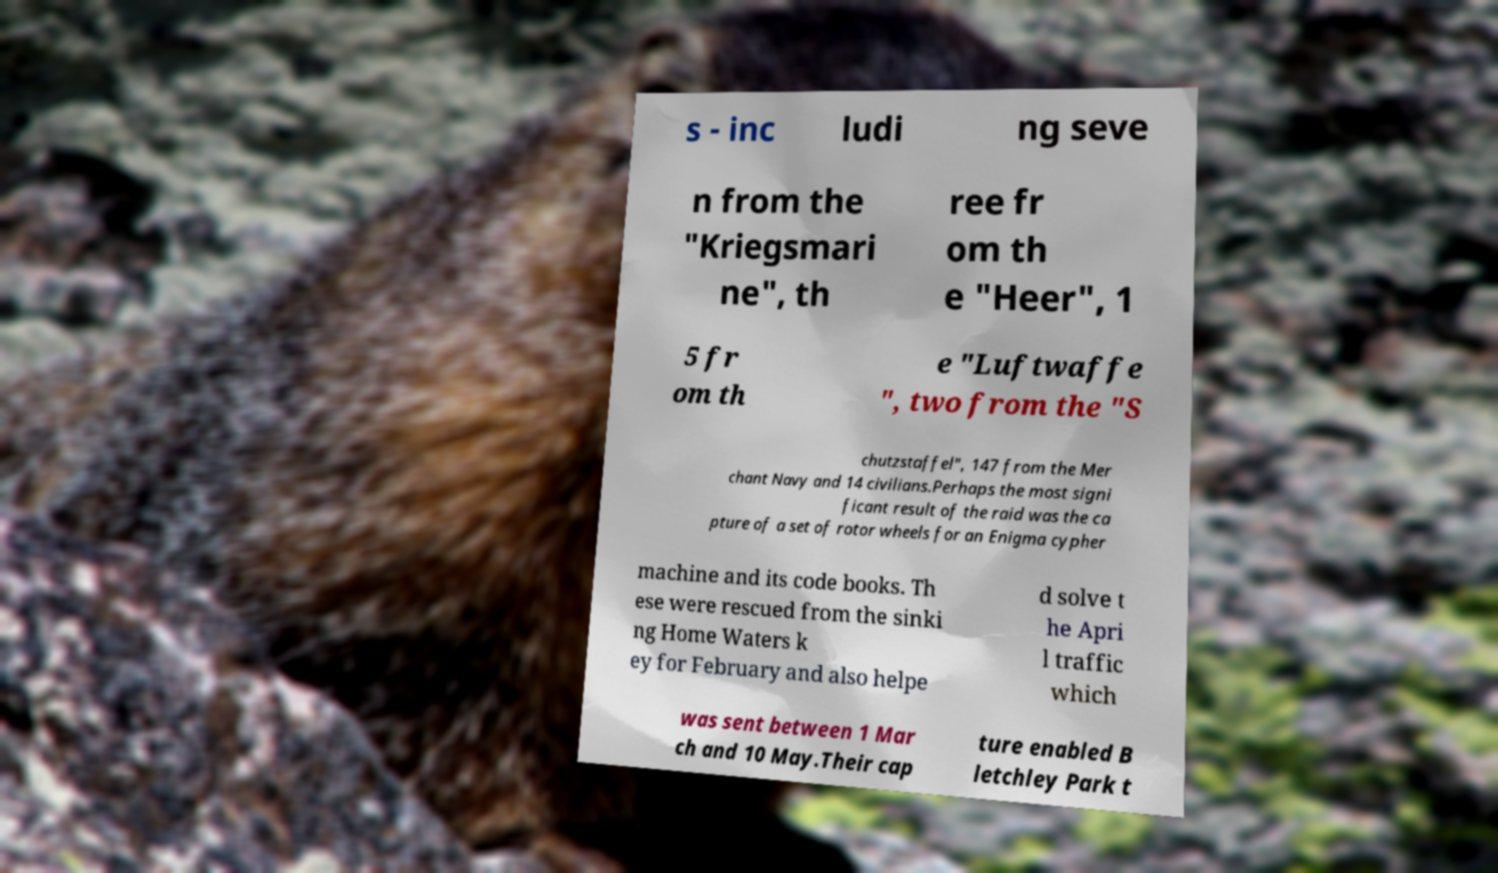Can you accurately transcribe the text from the provided image for me? s - inc ludi ng seve n from the "Kriegsmari ne", th ree fr om th e "Heer", 1 5 fr om th e "Luftwaffe ", two from the "S chutzstaffel", 147 from the Mer chant Navy and 14 civilians.Perhaps the most signi ficant result of the raid was the ca pture of a set of rotor wheels for an Enigma cypher machine and its code books. Th ese were rescued from the sinki ng Home Waters k ey for February and also helpe d solve t he Apri l traffic which was sent between 1 Mar ch and 10 May.Their cap ture enabled B letchley Park t 